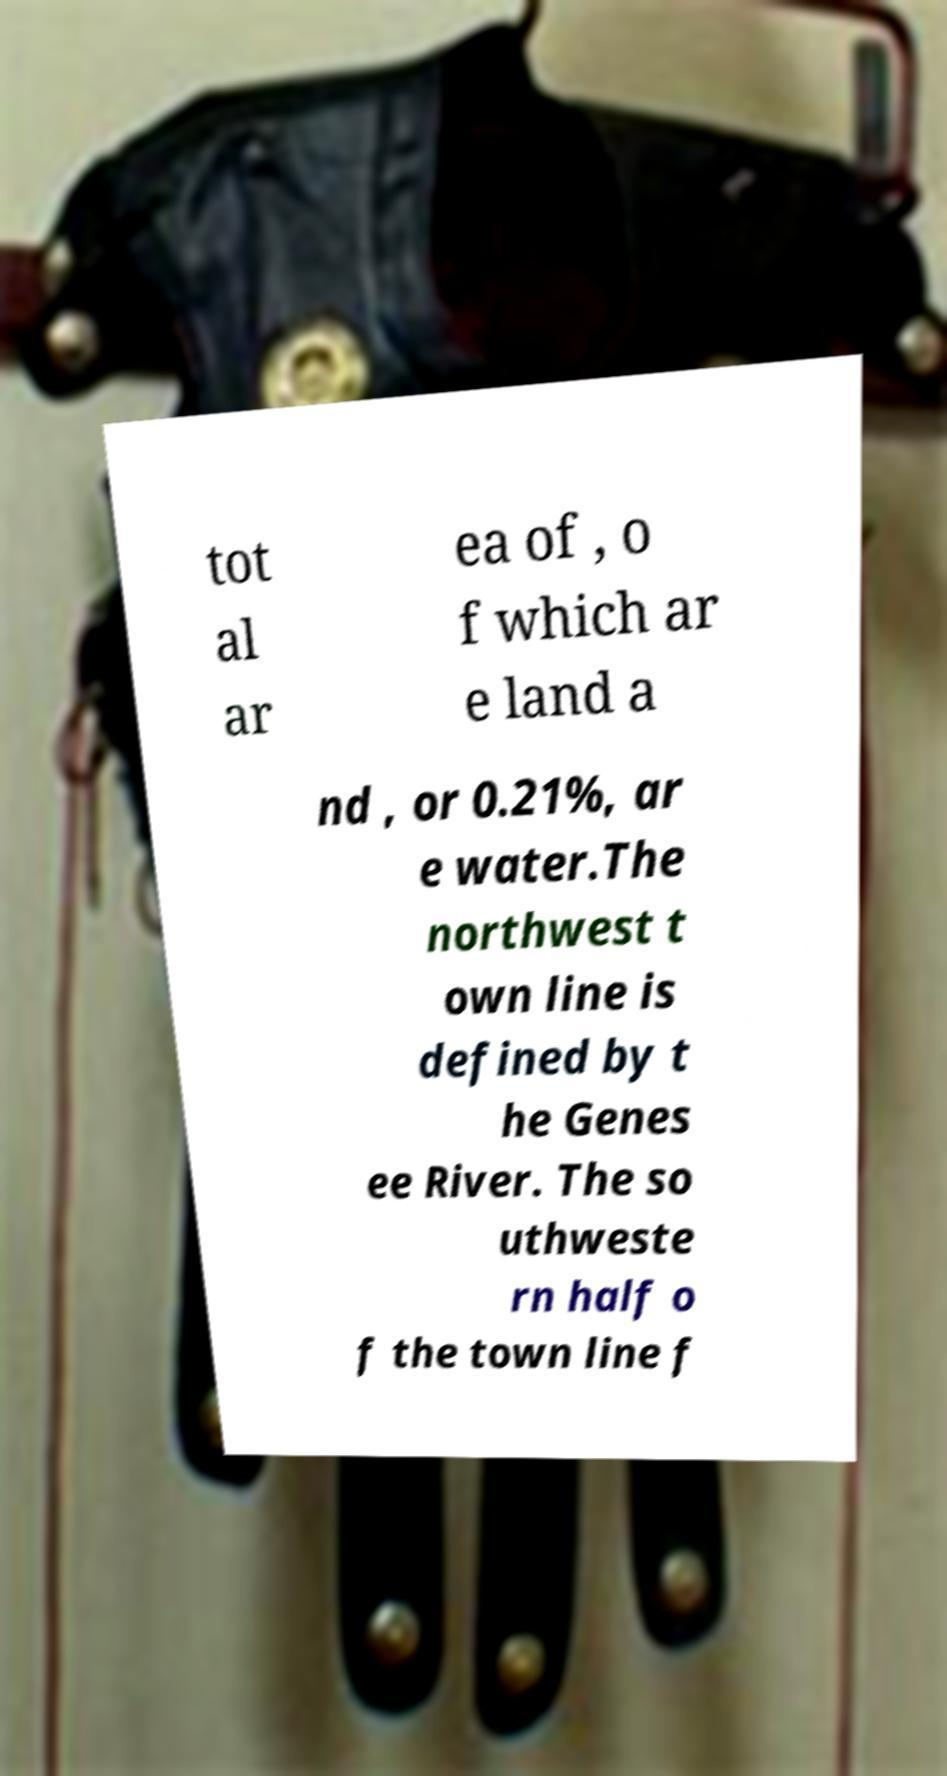Could you extract and type out the text from this image? tot al ar ea of , o f which ar e land a nd , or 0.21%, ar e water.The northwest t own line is defined by t he Genes ee River. The so uthweste rn half o f the town line f 